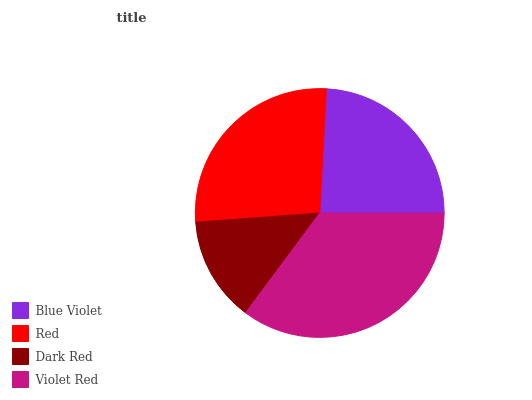Is Dark Red the minimum?
Answer yes or no. Yes. Is Violet Red the maximum?
Answer yes or no. Yes. Is Red the minimum?
Answer yes or no. No. Is Red the maximum?
Answer yes or no. No. Is Red greater than Blue Violet?
Answer yes or no. Yes. Is Blue Violet less than Red?
Answer yes or no. Yes. Is Blue Violet greater than Red?
Answer yes or no. No. Is Red less than Blue Violet?
Answer yes or no. No. Is Red the high median?
Answer yes or no. Yes. Is Blue Violet the low median?
Answer yes or no. Yes. Is Dark Red the high median?
Answer yes or no. No. Is Red the low median?
Answer yes or no. No. 